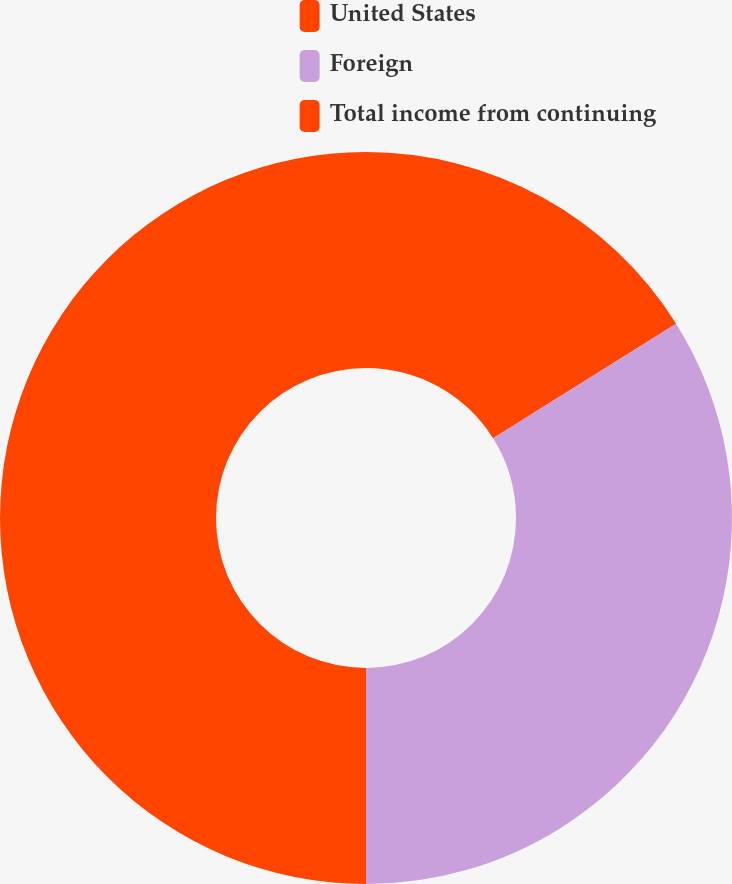Convert chart to OTSL. <chart><loc_0><loc_0><loc_500><loc_500><pie_chart><fcel>United States<fcel>Foreign<fcel>Total income from continuing<nl><fcel>16.09%<fcel>33.91%<fcel>50.0%<nl></chart> 